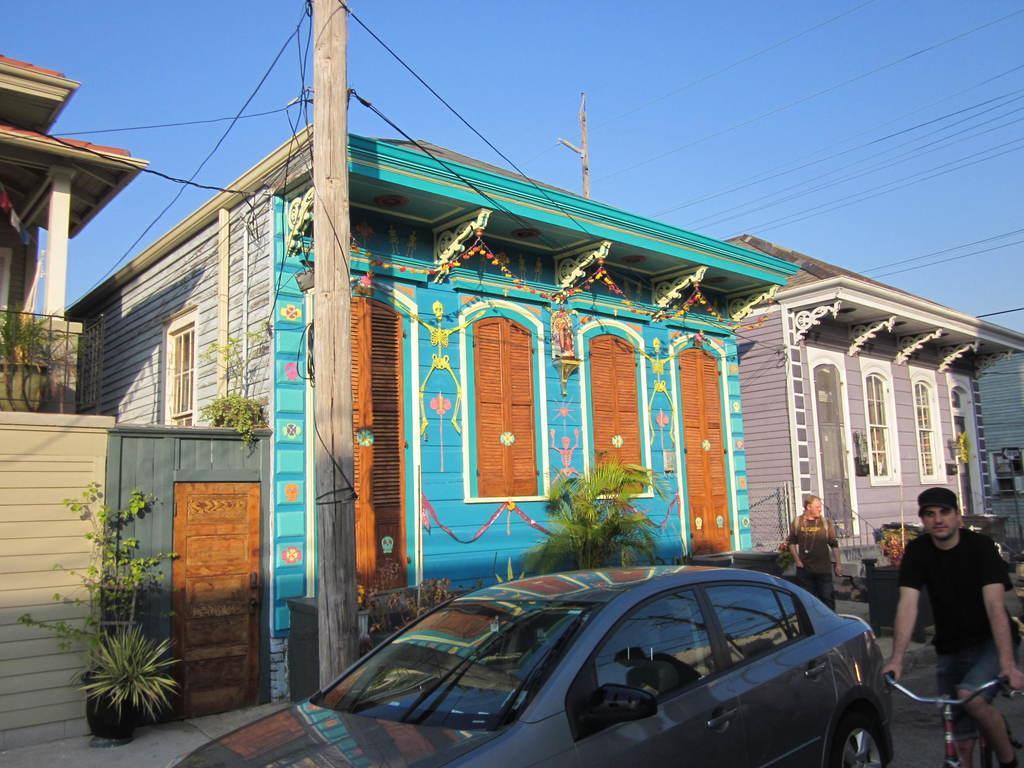Please provide a concise description of this image. In the picture we have a car and a man riding a bicycle and a person behind the car and also we have a current pole which has wires connected to the houses. We have two houses here, One of it has blue roof and the other has white color roof. The one which is blue colored roof has orange color windows and door The one with white roof has white color windows and also we can see some plants in front of the house. And some decorative hangings for the roof. 